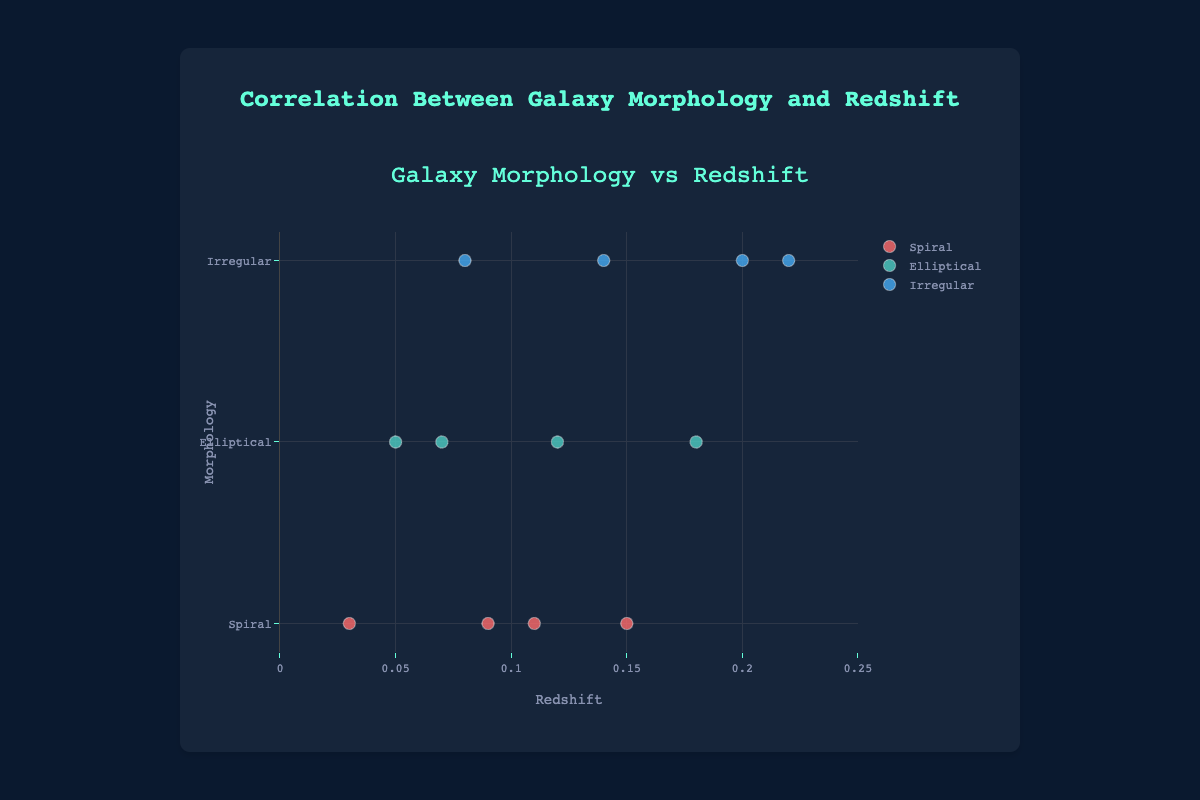What is the title of the scatter plot? The title of the scatter plot is usually prominently displayed above the plot itself, often in larger and bold text. In this case, the title is "Galaxy Morphology vs Redshift".
Answer: Galaxy Morphology vs Redshift What is the range of values on the x-axis (redshift)? Upon examining the plot, the range on the x-axis is clearly labeled, stretching from 0 to 0.25.
Answer: 0 to 0.25 How many spiral galaxies are displayed in the plot? The plot uses colors to denote different morphologies. By counting the markers corresponding to the color designated for 'Spiral' galaxies, you get the number.
Answer: 4 Which galaxy has the highest redshift value, and what is its morphology? From the scatter plot, identify the data point with the highest redshift value on the x-axis. The galaxy with a redshift of 0.22 is NGC 601, and it has 'Irregular' morphology.
Answer: NGC 601, Irregular Are there any types of morphology that appear only once on the plot? By observing the color groupings, each type of morphology appears multiple times; no type appears only once.
Answer: No How many elliptical galaxies have a redshift between 0.1 and 0.2? Inspect the plot for the markers that fall into the redshift range of 0.1 to 0.2 and are colored according to elliptical galaxies. There are two elliptical galaxies in this range.
Answer: 2 Which morphology category has the widest range of redshift values? Observing each morphology category, compare the spread of redshift values on the x-axis. The 'Irregular' category has galaxies ranging from 0.08 to 0.22 in redshift value, which is the widest range.
Answer: Irregular What is the average redshift value for spiral galaxies in the plot? Sum the redshift values of spiral galaxies (0.03, 0.15, 0.11, 0.09) and divide by the number of spiral galaxies (4). (0.03 + 0.15 + 0.11 + 0.09) / 4 = 0.095
Answer: 0.095 Compare the number of elliptical and irregular galaxies. Which is greater? By counting the markers for each morphology type, you'll notice there are 3 irregular and 4 elliptical galaxies, making elliptical greater.
Answer: Elliptical Which morphology shows the least variability in redshift values? Look at the range of redshift values for each morphology. The 'Spiral' galaxies range from 0.03 to 0.15, while 'Elliptical' range from 0.05 to 0.18, and 'Irregular' from 0.08 to 0.22. Spiral has the smallest range.
Answer: Spiral 